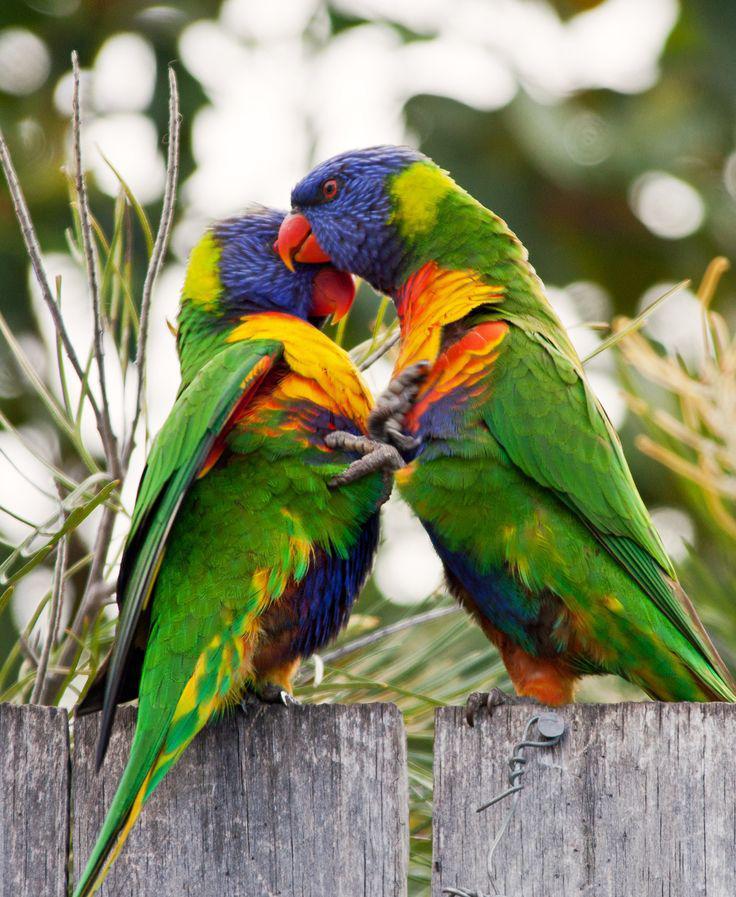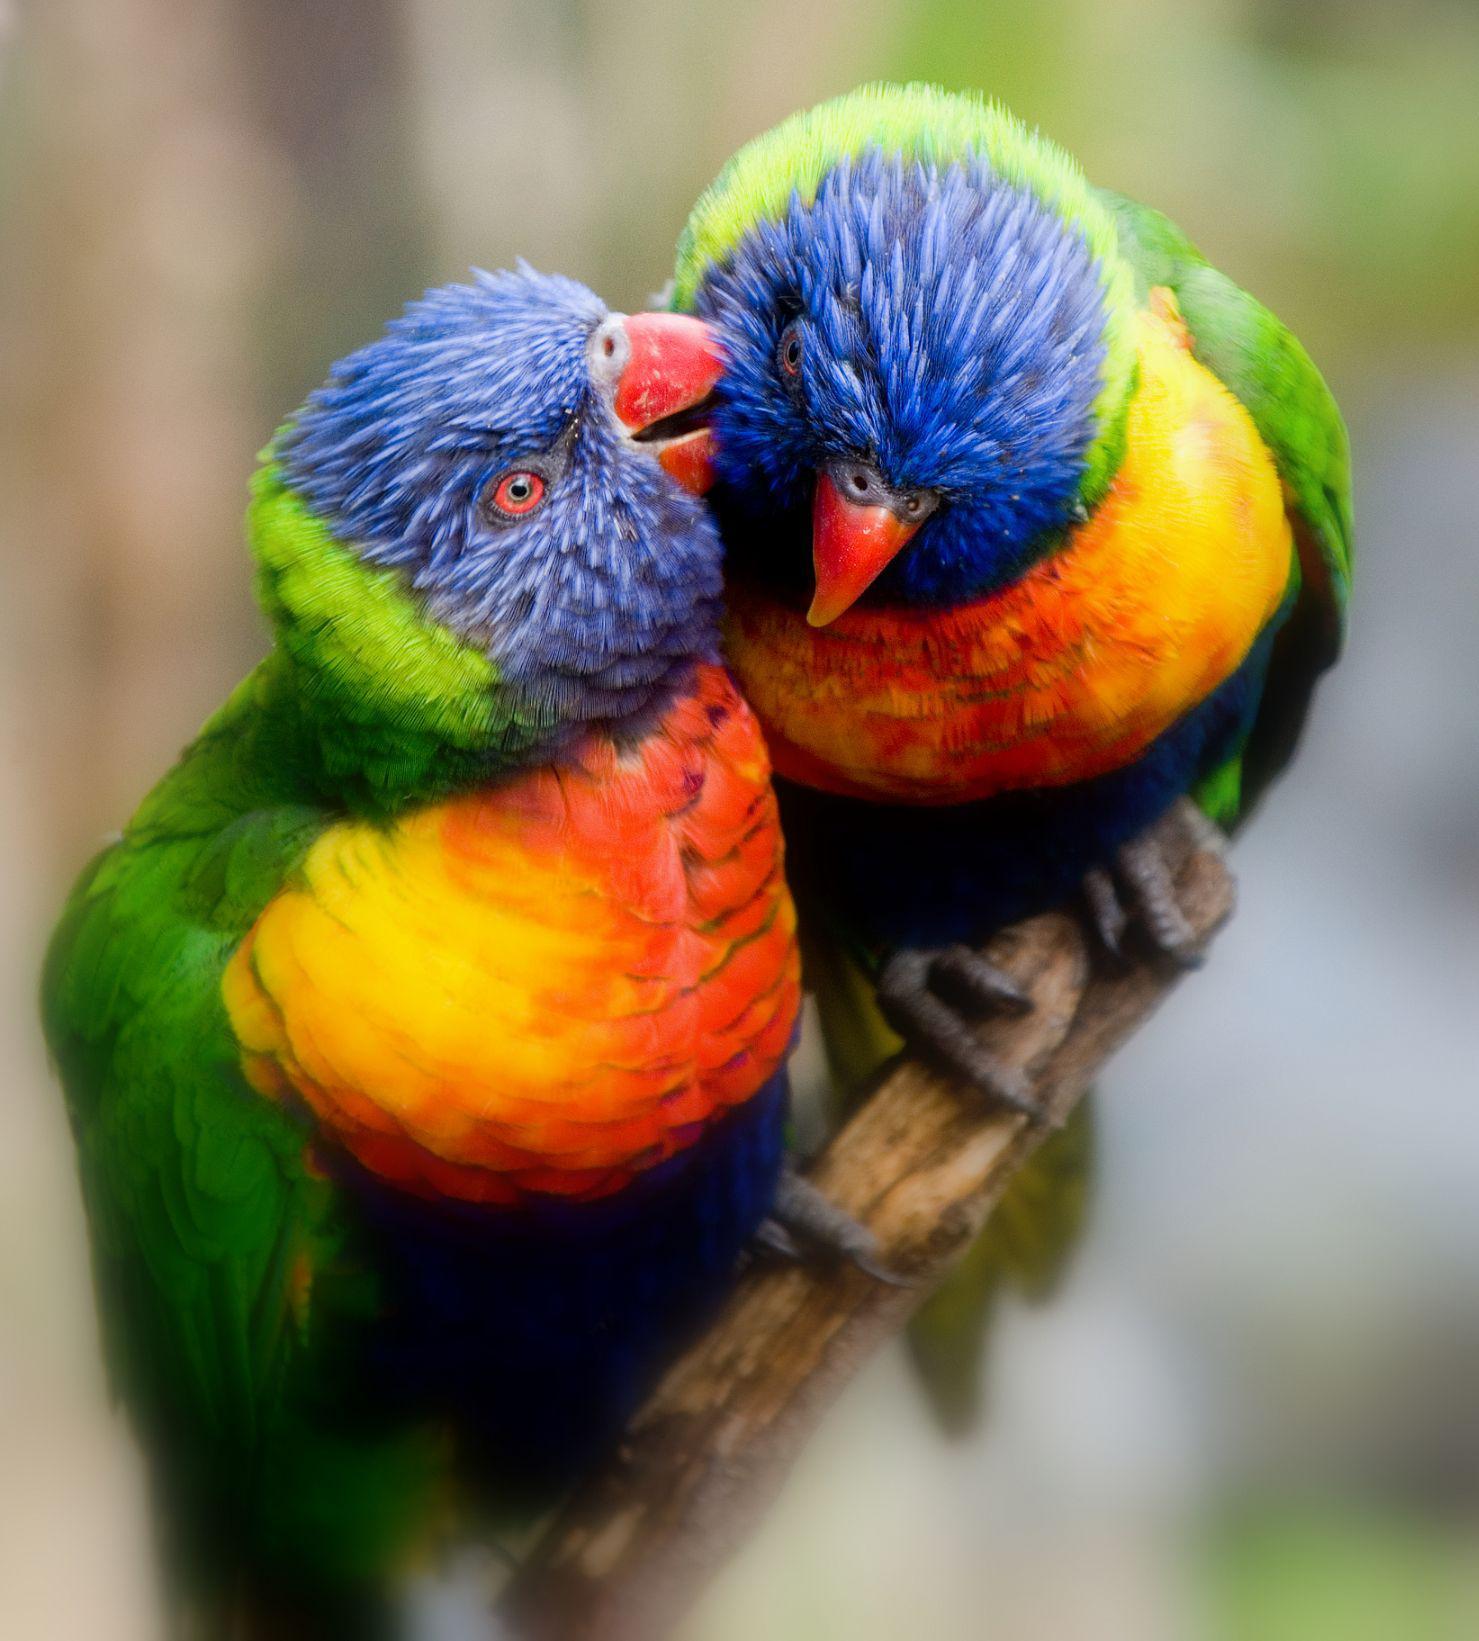The first image is the image on the left, the second image is the image on the right. For the images shown, is this caption "Two colorful birds are perched on a wooden fence." true? Answer yes or no. Yes. The first image is the image on the left, the second image is the image on the right. Examine the images to the left and right. Is the description "Each image depicts exactly two multi-colored parrots." accurate? Answer yes or no. Yes. 